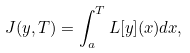Convert formula to latex. <formula><loc_0><loc_0><loc_500><loc_500>J ( y , T ) = \int _ { a } ^ { T } L [ y ] ( x ) d x ,</formula> 